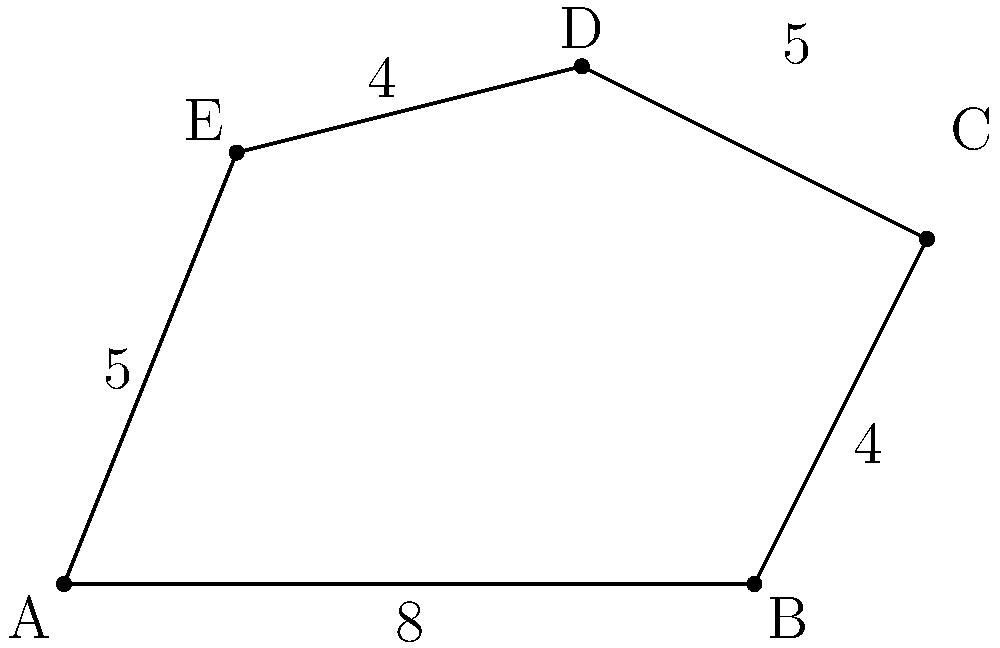As a GIS specialist working on an infrastructure project, you need to calculate the area of an irregular polygon representing a construction site. The site is depicted in the figure above, where the coordinates of the vertices are: A(0,0), B(8,0), C(10,4), D(6,6), and E(2,5). Calculate the area of this construction site using the coordinate method. To calculate the area of an irregular polygon using the coordinate method, we can use the following steps:

1. List the coordinates of all vertices in order (clockwise or counterclockwise).
2. Apply the shoelace formula: 
   $$Area = \frac{1}{2}|\sum_{i=1}^{n-1} (x_iy_{i+1} - x_{i+1}y_i) + (x_ny_1 - x_1y_n)|$$

Where $(x_i, y_i)$ are the coordinates of the $i$-th vertex.

3. Substitute the coordinates into the formula:

   $A(0,0)$, $B(8,0)$, $C(10,4)$, $D(6,6)$, $E(2,5)$

   $$\begin{align}
   Area &= \frac{1}{2}|(0 \cdot 0 - 8 \cdot 0) + (8 \cdot 4 - 10 \cdot 0) + (10 \cdot 6 - 6 \cdot 4)\\
   &+ (6 \cdot 5 - 2 \cdot 6) + (2 \cdot 0 - 0 \cdot 5)|
   \end{align}$$

4. Simplify:
   $$\begin{align}
   Area &= \frac{1}{2}|0 + 32 + 36 + 18 + 0|\\
   &= \frac{1}{2}(86)\\
   &= 43
   \end{align}$$

Therefore, the area of the construction site is 43 square units.
Answer: 43 square units 